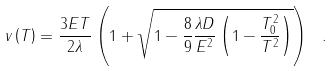Convert formula to latex. <formula><loc_0><loc_0><loc_500><loc_500>v \left ( T \right ) = \frac { 3 E T } { 2 \lambda } \left ( 1 + \sqrt { 1 - \frac { 8 } { 9 } \frac { \lambda D } { E ^ { 2 } } \left ( 1 - \frac { T _ { 0 } ^ { 2 } } { T ^ { 2 } } \right ) } \right ) \ .</formula> 